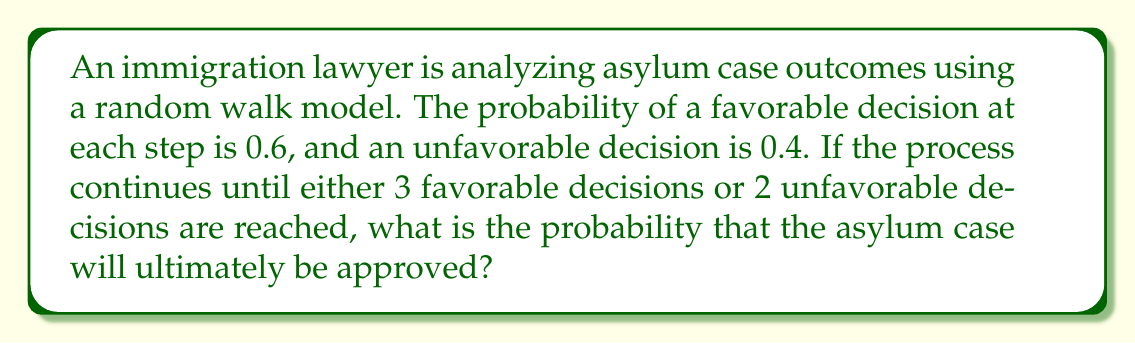Give your solution to this math problem. Let's approach this step-by-step using a random walk process:

1) We can model this as a Markov chain with absorbing states. The states are:
   (0,0) - starting point
   (1,0), (2,0), (3,0) - 1, 2, and 3 favorable decisions
   (0,1), (1,1), (2,1) - 1 unfavorable and 0, 1, or 2 favorable decisions
   (0,2) - 2 unfavorable decisions

2) The absorbing states are (3,0) for approval and (0,2) or (1,2) or (2,2) for denial.

3) Let $P(x,y)$ be the probability of ultimate approval starting from state $(x,y)$.

4) We can set up the following equations:

   $P(3,0) = 1$ (absorbing state for approval)
   $P(0,2) = P(1,2) = P(2,2) = 0$ (absorbing states for denial)

   For other states:
   $P(x,y) = 0.6 \cdot P(x+1,y) + 0.4 \cdot P(x,y+1)$

5) This gives us:

   $P(2,0) = 0.6 \cdot 1 + 0.4 \cdot P(2,1) = 0.6 + 0.4P(2,1)$
   $P(1,0) = 0.6 \cdot P(2,0) + 0.4 \cdot P(1,1)$
   $P(0,0) = 0.6 \cdot P(1,0) + 0.4 \cdot P(0,1)$
   $P(2,1) = 0.6 \cdot 1 + 0.4 \cdot 0 = 0.6$
   $P(1,1) = 0.6 \cdot P(2,1) + 0.4 \cdot 0 = 0.36$
   $P(0,1) = 0.6 \cdot P(1,1) + 0.4 \cdot 0 = 0.216$

6) Substituting back:

   $P(2,0) = 0.6 + 0.4 \cdot 0.6 = 0.84$
   $P(1,0) = 0.6 \cdot 0.84 + 0.4 \cdot 0.36 = 0.648$
   $P(0,0) = 0.6 \cdot 0.648 + 0.4 \cdot 0.216 = 0.4752$

7) Therefore, the probability of the asylum case being ultimately approved, starting from (0,0), is 0.4752 or about 47.52%.
Answer: $0.4752$ or $47.52\%$ 